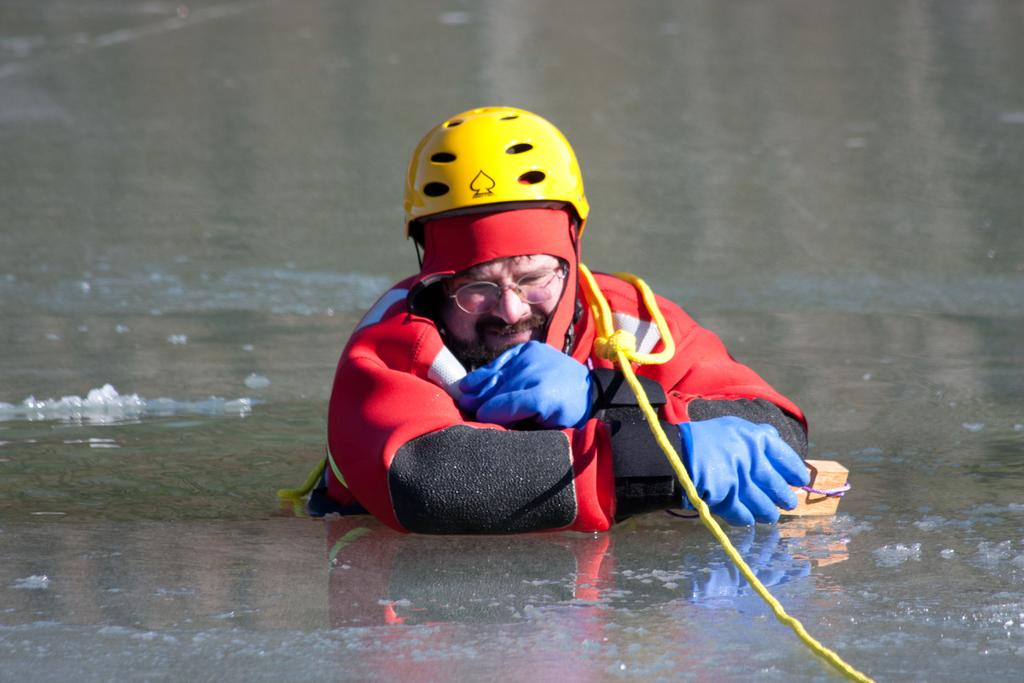What can be seen in the image? There is a person in the image. What is the person wearing? The person is wearing a helmet. What is the person holding? The person is holding an object. What is the setting of the image? The person is in water. What is present in front of the person? There is a rope in front of the person. What type of crack can be seen on the person's chin in the image? There is no crack visible on the person's chin in the image. 